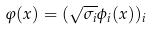Convert formula to latex. <formula><loc_0><loc_0><loc_500><loc_500>\varphi ( x ) = ( \sqrt { \sigma _ { i } } \phi _ { i } ( x ) ) _ { i }</formula> 